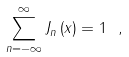Convert formula to latex. <formula><loc_0><loc_0><loc_500><loc_500>\sum _ { n = - \infty } ^ { \infty } J _ { n } \left ( x \right ) = 1 \ ,</formula> 